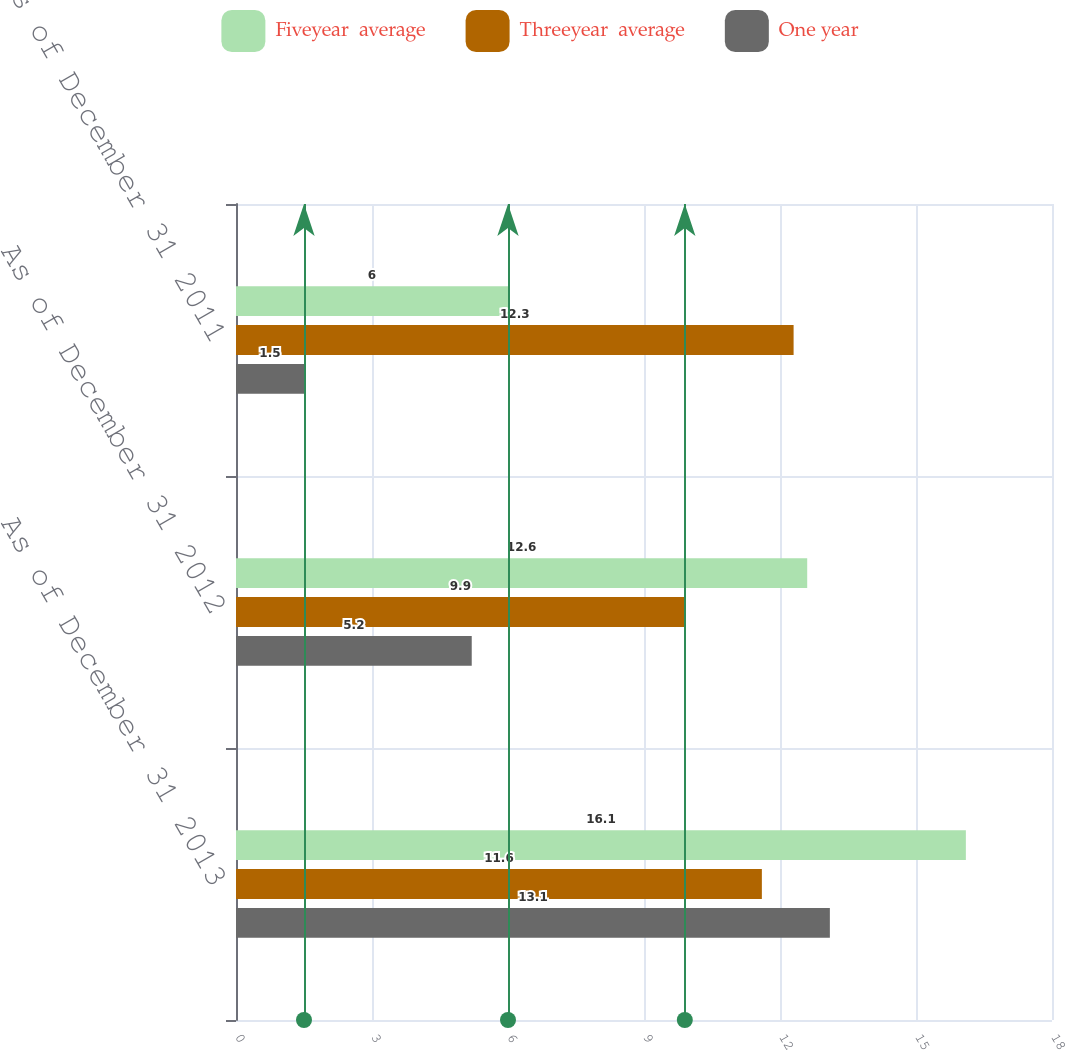Convert chart. <chart><loc_0><loc_0><loc_500><loc_500><stacked_bar_chart><ecel><fcel>As of December 31 2013<fcel>As of December 31 2012<fcel>As of December 31 2011<nl><fcel>Fiveyear  average<fcel>16.1<fcel>12.6<fcel>6<nl><fcel>Threeyear  average<fcel>11.6<fcel>9.9<fcel>12.3<nl><fcel>One year<fcel>13.1<fcel>5.2<fcel>1.5<nl></chart> 